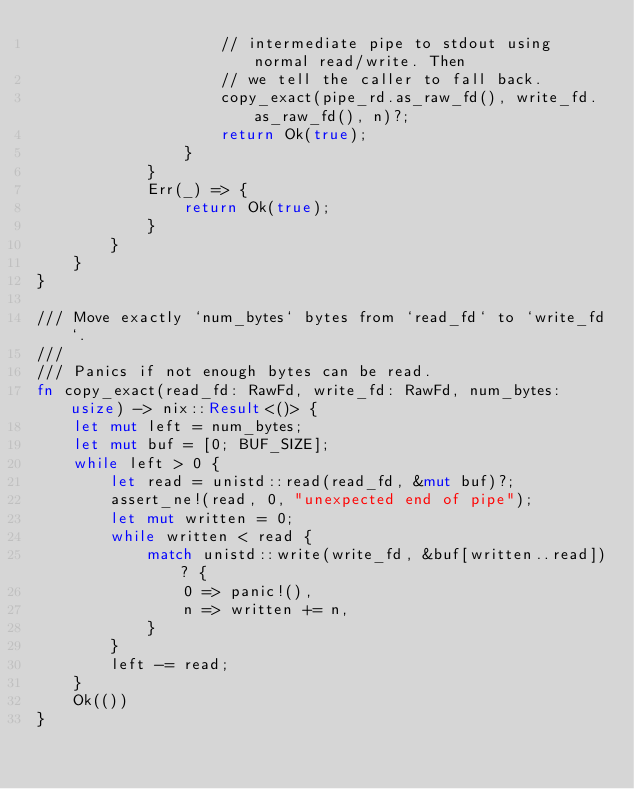<code> <loc_0><loc_0><loc_500><loc_500><_Rust_>                    // intermediate pipe to stdout using normal read/write. Then
                    // we tell the caller to fall back.
                    copy_exact(pipe_rd.as_raw_fd(), write_fd.as_raw_fd(), n)?;
                    return Ok(true);
                }
            }
            Err(_) => {
                return Ok(true);
            }
        }
    }
}

/// Move exactly `num_bytes` bytes from `read_fd` to `write_fd`.
///
/// Panics if not enough bytes can be read.
fn copy_exact(read_fd: RawFd, write_fd: RawFd, num_bytes: usize) -> nix::Result<()> {
    let mut left = num_bytes;
    let mut buf = [0; BUF_SIZE];
    while left > 0 {
        let read = unistd::read(read_fd, &mut buf)?;
        assert_ne!(read, 0, "unexpected end of pipe");
        let mut written = 0;
        while written < read {
            match unistd::write(write_fd, &buf[written..read])? {
                0 => panic!(),
                n => written += n,
            }
        }
        left -= read;
    }
    Ok(())
}
</code> 